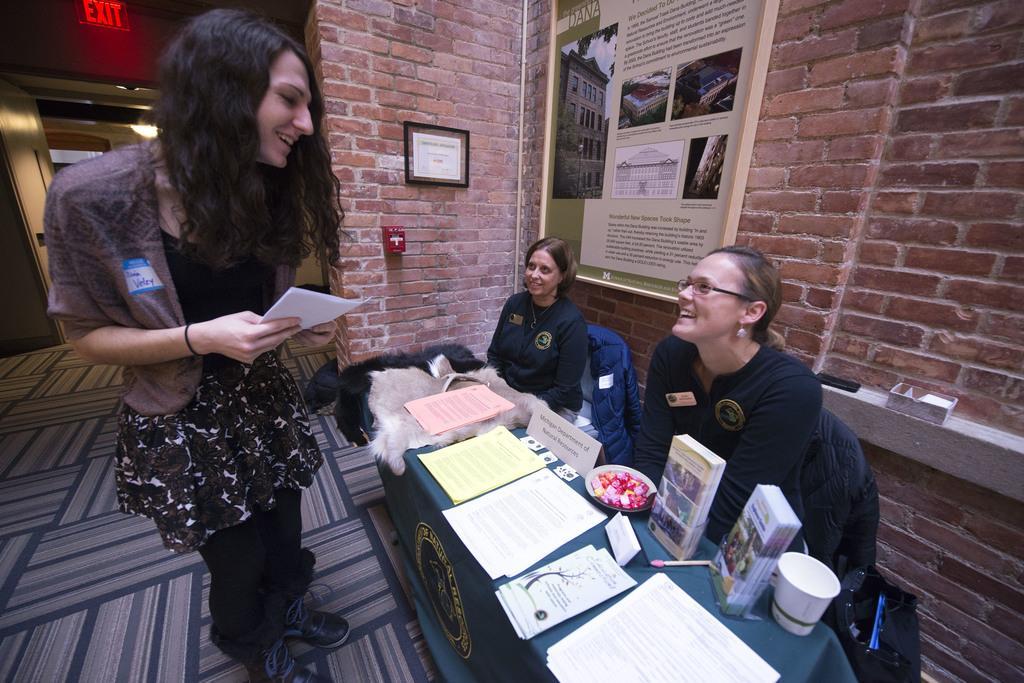Could you give a brief overview of what you see in this image? In this image there are two people sitting on the chairs and they are smiling. In front of them there is a table. On top of it there are papers, books. There is a cup and a few other objects. In front of the table there is a person standing on the mat and she is holding the papers. In the background of the image there are photo frames on the wall. There are a few objects on the platform. There is an exit board. There is an open door. 